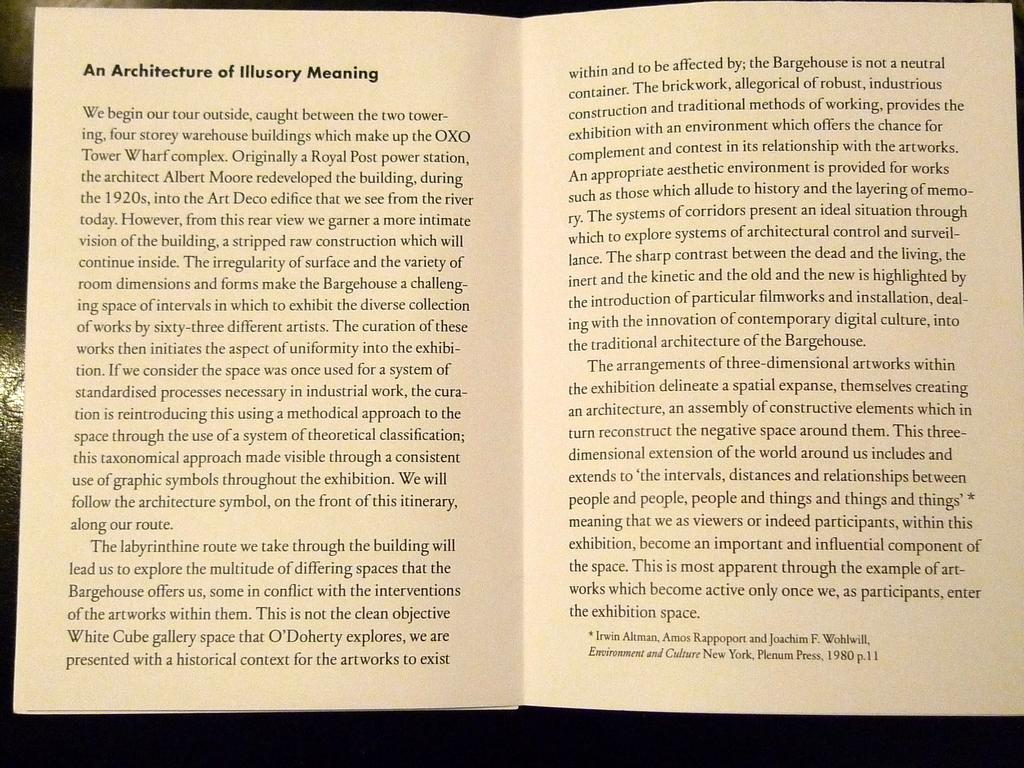<image>
Render a clear and concise summary of the photo. An open text book with the title of An Architecture of Illusory Meaning on it. 